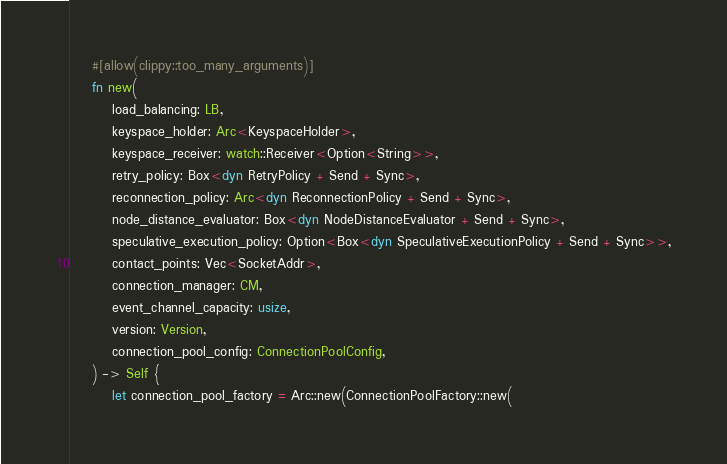<code> <loc_0><loc_0><loc_500><loc_500><_Rust_>
    #[allow(clippy::too_many_arguments)]
    fn new(
        load_balancing: LB,
        keyspace_holder: Arc<KeyspaceHolder>,
        keyspace_receiver: watch::Receiver<Option<String>>,
        retry_policy: Box<dyn RetryPolicy + Send + Sync>,
        reconnection_policy: Arc<dyn ReconnectionPolicy + Send + Sync>,
        node_distance_evaluator: Box<dyn NodeDistanceEvaluator + Send + Sync>,
        speculative_execution_policy: Option<Box<dyn SpeculativeExecutionPolicy + Send + Sync>>,
        contact_points: Vec<SocketAddr>,
        connection_manager: CM,
        event_channel_capacity: usize,
        version: Version,
        connection_pool_config: ConnectionPoolConfig,
    ) -> Self {
        let connection_pool_factory = Arc::new(ConnectionPoolFactory::new(</code> 